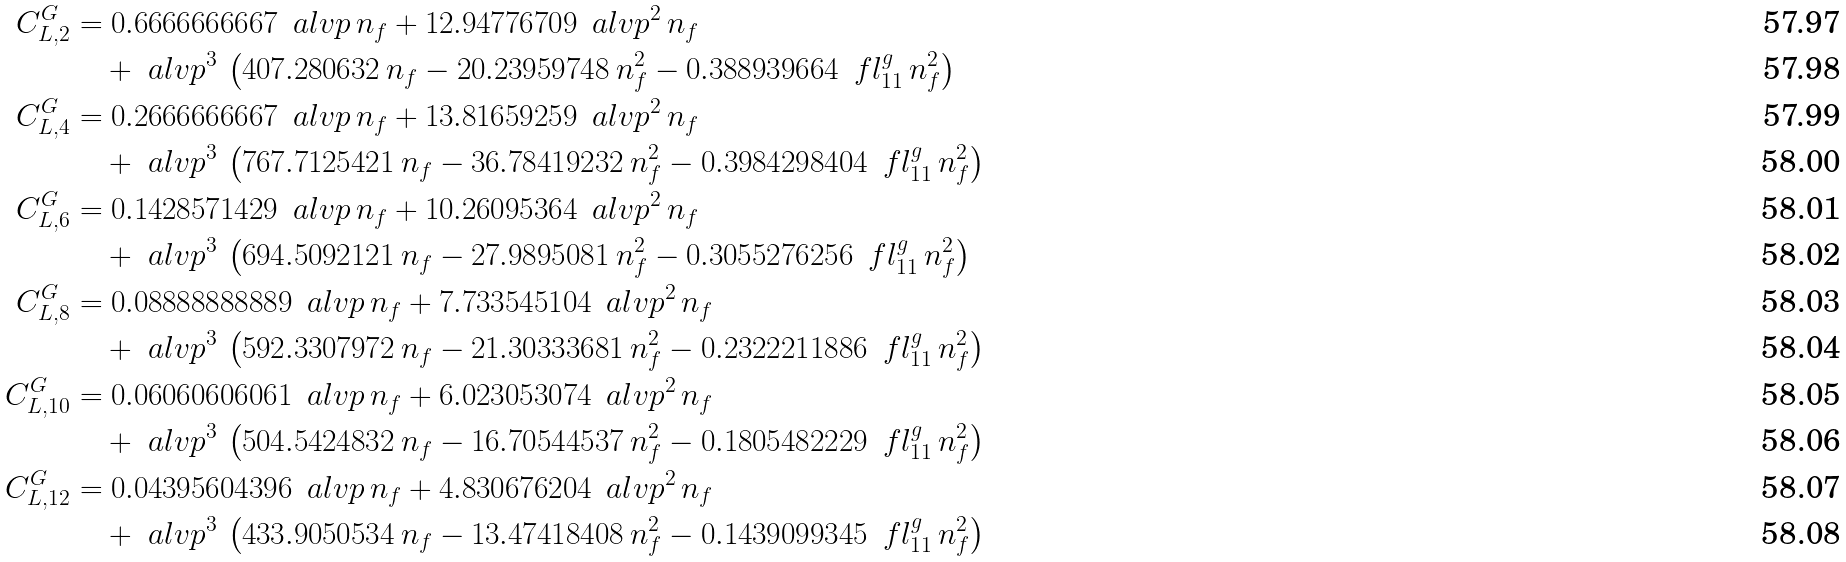<formula> <loc_0><loc_0><loc_500><loc_500>C ^ { G } _ { L , 2 } & = 0 . 6 6 6 6 6 6 6 6 6 7 \, \ a l v p \, n _ { f } + 1 2 . 9 4 7 7 6 7 0 9 \, { \ a l v p ^ { 2 } } \, n _ { f } & \\ & \quad + \ a l v p ^ { 3 } \, \left ( 4 0 7 . 2 8 0 6 3 2 \, n _ { f } - 2 0 . 2 3 9 5 9 7 4 8 \, { n _ { f } ^ { 2 } } - 0 . 3 8 8 9 3 9 6 6 4 \, \ f l ^ { g } _ { 1 1 } \, { n _ { f } ^ { 2 } } \right ) & \\ C ^ { G } _ { L , 4 } & = 0 . 2 6 6 6 6 6 6 6 6 7 \, \ a l v p \, n _ { f } + 1 3 . 8 1 6 5 9 2 5 9 \, { \ a l v p ^ { 2 } } \, n _ { f } & \\ & \quad + \ a l v p ^ { 3 } \, \left ( 7 6 7 . 7 1 2 5 4 2 1 \, n _ { f } - 3 6 . 7 8 4 1 9 2 3 2 \, { n _ { f } ^ { 2 } } - 0 . 3 9 8 4 2 9 8 4 0 4 \, \ f l ^ { g } _ { 1 1 } \, { n _ { f } ^ { 2 } } \right ) & \\ C ^ { G } _ { L , 6 } & = 0 . 1 4 2 8 5 7 1 4 2 9 \, \ a l v p \, n _ { f } + 1 0 . 2 6 0 9 5 3 6 4 \, { \ a l v p ^ { 2 } } \, n _ { f } & \\ & \quad + \ a l v p ^ { 3 } \, \left ( 6 9 4 . 5 0 9 2 1 2 1 \, n _ { f } - 2 7 . 9 8 9 5 0 8 1 \, { n _ { f } ^ { 2 } } - 0 . 3 0 5 5 2 7 6 2 5 6 \, \ f l ^ { g } _ { 1 1 } \, { n _ { f } ^ { 2 } } \right ) & \\ C ^ { G } _ { L , 8 } & = 0 . 0 8 8 8 8 8 8 8 8 8 9 \, \ a l v p \, n _ { f } + 7 . 7 3 3 5 4 5 1 0 4 \, { \ a l v p ^ { 2 } } \, n _ { f } & \\ & \quad + \ a l v p ^ { 3 } \, \left ( 5 9 2 . 3 3 0 7 9 7 2 \, n _ { f } - 2 1 . 3 0 3 3 3 6 8 1 \, { n _ { f } ^ { 2 } } - 0 . 2 3 2 2 2 1 1 8 8 6 \, \ f l ^ { g } _ { 1 1 } \, { n _ { f } ^ { 2 } } \right ) & \\ C ^ { G } _ { L , 1 0 } & = 0 . 0 6 0 6 0 6 0 6 0 6 1 \, \ a l v p \, n _ { f } + 6 . 0 2 3 0 5 3 0 7 4 \, { \ a l v p ^ { 2 } } \, n _ { f } & \\ & \quad + \ a l v p ^ { 3 } \, \left ( 5 0 4 . 5 4 2 4 8 3 2 \, n _ { f } - 1 6 . 7 0 5 4 4 5 3 7 \, { n _ { f } ^ { 2 } } - 0 . 1 8 0 5 4 8 2 2 2 9 \, \ f l ^ { g } _ { 1 1 } \, { n _ { f } ^ { 2 } } \right ) & \\ C ^ { G } _ { L , 1 2 } & = 0 . 0 4 3 9 5 6 0 4 3 9 6 \, \ a l v p \, n _ { f } + 4 . 8 3 0 6 7 6 2 0 4 \, { \ a l v p ^ { 2 } } \, n _ { f } & \\ & \quad + \ a l v p ^ { 3 } \, \left ( 4 3 3 . 9 0 5 0 5 3 4 \, n _ { f } - 1 3 . 4 7 4 1 8 4 0 8 \, { n _ { f } ^ { 2 } } - 0 . 1 4 3 9 0 9 9 3 4 5 \, \ f l ^ { g } _ { 1 1 } \, { n _ { f } ^ { 2 } } \right ) &</formula> 